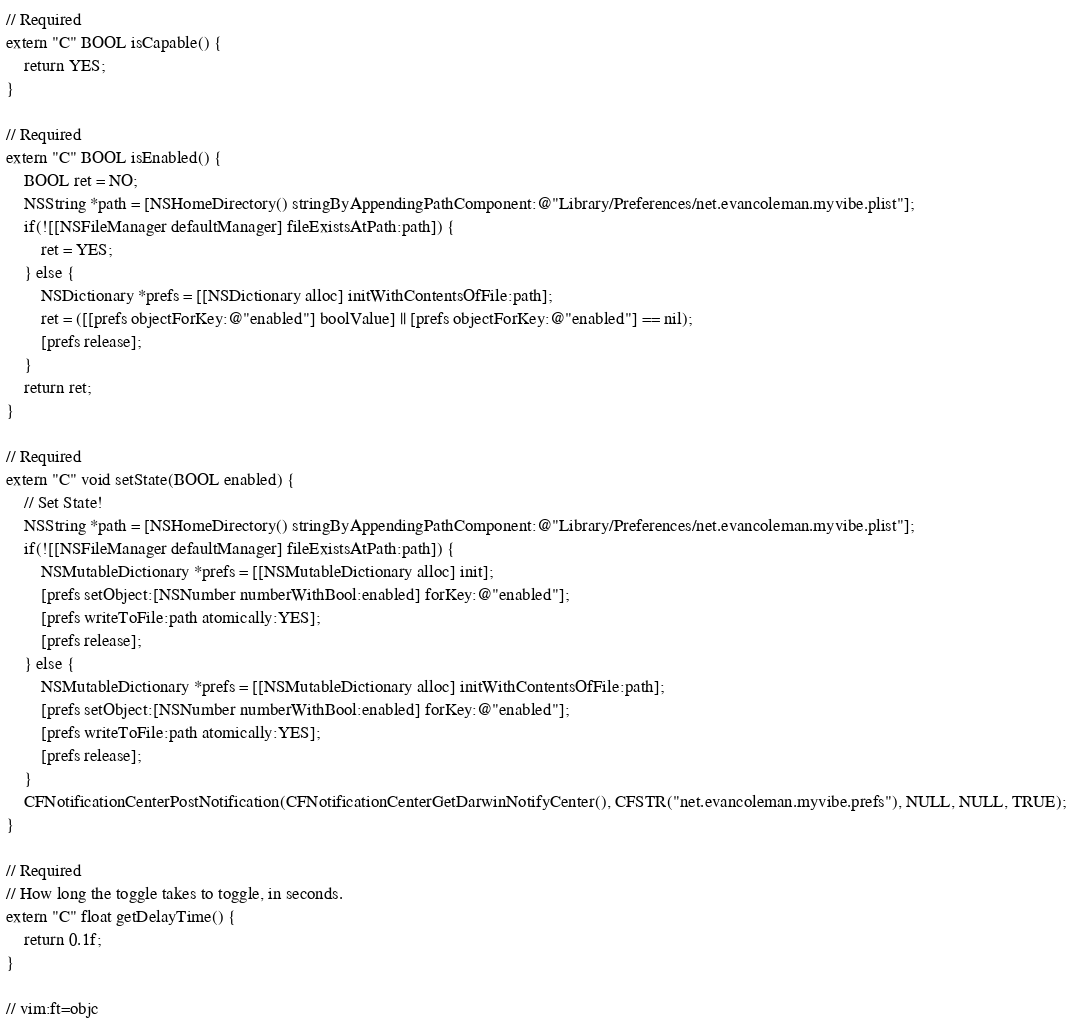Convert code to text. <code><loc_0><loc_0><loc_500><loc_500><_ObjectiveC_>// Required
extern "C" BOOL isCapable() {
	return YES;
}

// Required
extern "C" BOOL isEnabled() {
	BOOL ret = NO;
	NSString *path = [NSHomeDirectory() stringByAppendingPathComponent:@"Library/Preferences/net.evancoleman.myvibe.plist"];
	if(![[NSFileManager defaultManager] fileExistsAtPath:path]) {
		ret = YES;
	} else {
		NSDictionary *prefs = [[NSDictionary alloc] initWithContentsOfFile:path];
		ret = ([[prefs objectForKey:@"enabled"] boolValue] || [prefs objectForKey:@"enabled"] == nil);
		[prefs release];
	}
	return ret;
}

// Required
extern "C" void setState(BOOL enabled) {
	// Set State!
	NSString *path = [NSHomeDirectory() stringByAppendingPathComponent:@"Library/Preferences/net.evancoleman.myvibe.plist"];
	if(![[NSFileManager defaultManager] fileExistsAtPath:path]) {
		NSMutableDictionary *prefs = [[NSMutableDictionary alloc] init];
		[prefs setObject:[NSNumber numberWithBool:enabled] forKey:@"enabled"];
		[prefs writeToFile:path atomically:YES];
		[prefs release];
	} else {
		NSMutableDictionary *prefs = [[NSMutableDictionary alloc] initWithContentsOfFile:path];
		[prefs setObject:[NSNumber numberWithBool:enabled] forKey:@"enabled"];
		[prefs writeToFile:path atomically:YES];
		[prefs release];
	}
	CFNotificationCenterPostNotification(CFNotificationCenterGetDarwinNotifyCenter(), CFSTR("net.evancoleman.myvibe.prefs"), NULL, NULL, TRUE);
}

// Required
// How long the toggle takes to toggle, in seconds.
extern "C" float getDelayTime() {
	return 0.1f;
}

// vim:ft=objc
</code> 